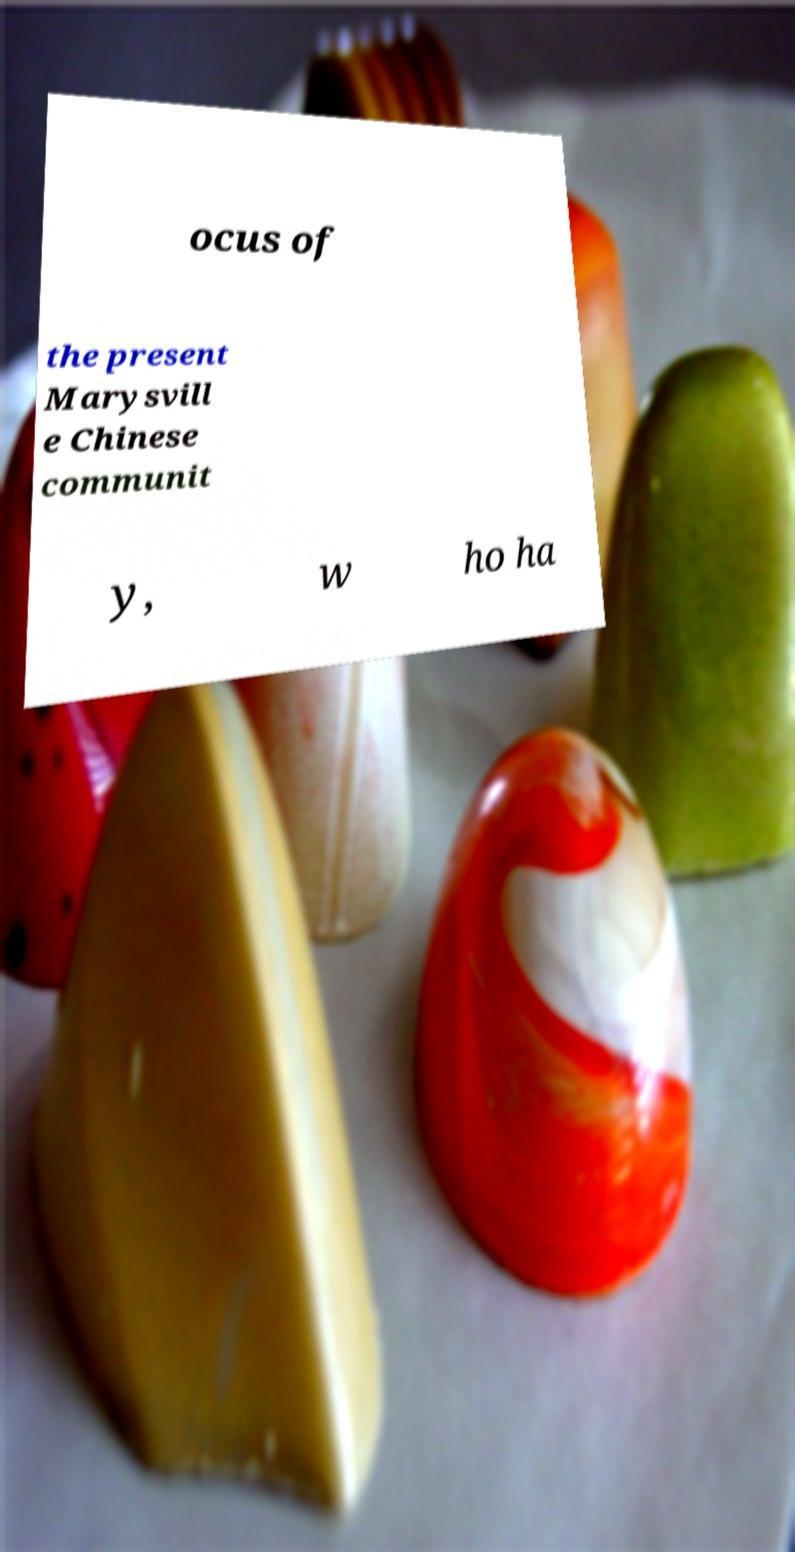There's text embedded in this image that I need extracted. Can you transcribe it verbatim? ocus of the present Marysvill e Chinese communit y, w ho ha 